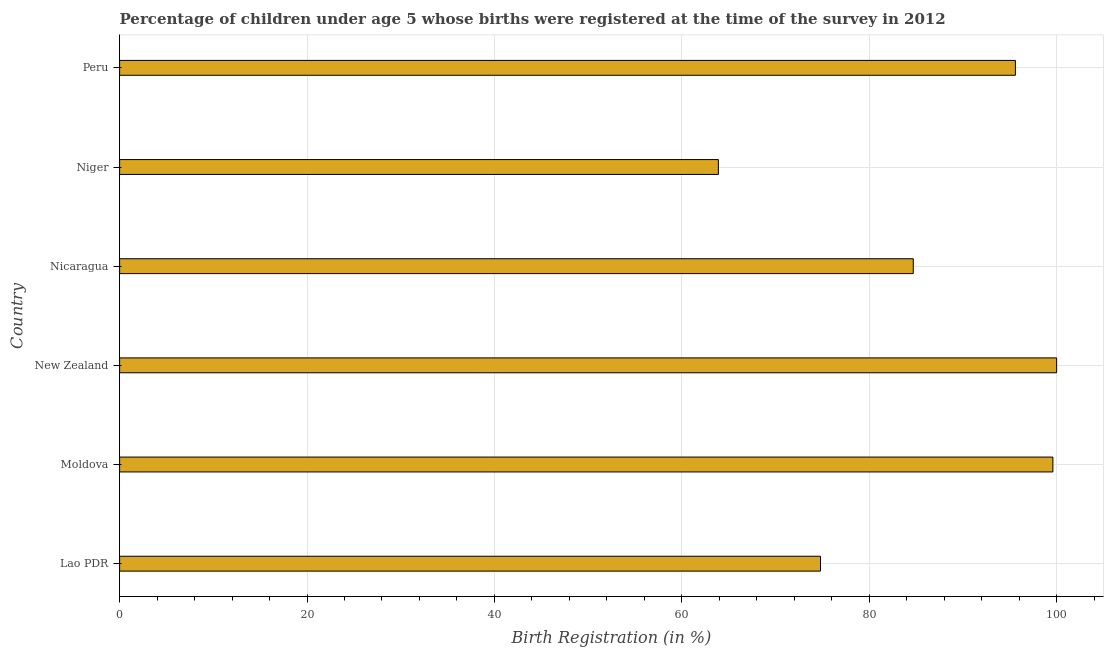Does the graph contain grids?
Keep it short and to the point. Yes. What is the title of the graph?
Your answer should be very brief. Percentage of children under age 5 whose births were registered at the time of the survey in 2012. What is the label or title of the X-axis?
Make the answer very short. Birth Registration (in %). What is the label or title of the Y-axis?
Your answer should be very brief. Country. What is the birth registration in Peru?
Give a very brief answer. 95.6. Across all countries, what is the maximum birth registration?
Keep it short and to the point. 100. Across all countries, what is the minimum birth registration?
Keep it short and to the point. 63.9. In which country was the birth registration maximum?
Offer a very short reply. New Zealand. In which country was the birth registration minimum?
Make the answer very short. Niger. What is the sum of the birth registration?
Provide a short and direct response. 518.6. What is the average birth registration per country?
Keep it short and to the point. 86.43. What is the median birth registration?
Provide a succinct answer. 90.15. In how many countries, is the birth registration greater than 52 %?
Ensure brevity in your answer.  6. What is the ratio of the birth registration in Lao PDR to that in Peru?
Ensure brevity in your answer.  0.78. What is the difference between the highest and the lowest birth registration?
Give a very brief answer. 36.1. In how many countries, is the birth registration greater than the average birth registration taken over all countries?
Your response must be concise. 3. How many bars are there?
Make the answer very short. 6. Are all the bars in the graph horizontal?
Your answer should be compact. Yes. How many countries are there in the graph?
Ensure brevity in your answer.  6. Are the values on the major ticks of X-axis written in scientific E-notation?
Provide a succinct answer. No. What is the Birth Registration (in %) in Lao PDR?
Your answer should be very brief. 74.8. What is the Birth Registration (in %) of Moldova?
Ensure brevity in your answer.  99.6. What is the Birth Registration (in %) of New Zealand?
Provide a succinct answer. 100. What is the Birth Registration (in %) in Nicaragua?
Your response must be concise. 84.7. What is the Birth Registration (in %) of Niger?
Provide a succinct answer. 63.9. What is the Birth Registration (in %) in Peru?
Give a very brief answer. 95.6. What is the difference between the Birth Registration (in %) in Lao PDR and Moldova?
Your answer should be compact. -24.8. What is the difference between the Birth Registration (in %) in Lao PDR and New Zealand?
Keep it short and to the point. -25.2. What is the difference between the Birth Registration (in %) in Lao PDR and Nicaragua?
Your answer should be compact. -9.9. What is the difference between the Birth Registration (in %) in Lao PDR and Peru?
Ensure brevity in your answer.  -20.8. What is the difference between the Birth Registration (in %) in Moldova and New Zealand?
Your answer should be compact. -0.4. What is the difference between the Birth Registration (in %) in Moldova and Nicaragua?
Your answer should be very brief. 14.9. What is the difference between the Birth Registration (in %) in Moldova and Niger?
Your answer should be compact. 35.7. What is the difference between the Birth Registration (in %) in Moldova and Peru?
Offer a very short reply. 4. What is the difference between the Birth Registration (in %) in New Zealand and Nicaragua?
Give a very brief answer. 15.3. What is the difference between the Birth Registration (in %) in New Zealand and Niger?
Make the answer very short. 36.1. What is the difference between the Birth Registration (in %) in New Zealand and Peru?
Provide a succinct answer. 4.4. What is the difference between the Birth Registration (in %) in Nicaragua and Niger?
Make the answer very short. 20.8. What is the difference between the Birth Registration (in %) in Nicaragua and Peru?
Keep it short and to the point. -10.9. What is the difference between the Birth Registration (in %) in Niger and Peru?
Ensure brevity in your answer.  -31.7. What is the ratio of the Birth Registration (in %) in Lao PDR to that in Moldova?
Make the answer very short. 0.75. What is the ratio of the Birth Registration (in %) in Lao PDR to that in New Zealand?
Your response must be concise. 0.75. What is the ratio of the Birth Registration (in %) in Lao PDR to that in Nicaragua?
Your response must be concise. 0.88. What is the ratio of the Birth Registration (in %) in Lao PDR to that in Niger?
Provide a succinct answer. 1.17. What is the ratio of the Birth Registration (in %) in Lao PDR to that in Peru?
Offer a terse response. 0.78. What is the ratio of the Birth Registration (in %) in Moldova to that in Nicaragua?
Offer a terse response. 1.18. What is the ratio of the Birth Registration (in %) in Moldova to that in Niger?
Keep it short and to the point. 1.56. What is the ratio of the Birth Registration (in %) in Moldova to that in Peru?
Provide a short and direct response. 1.04. What is the ratio of the Birth Registration (in %) in New Zealand to that in Nicaragua?
Keep it short and to the point. 1.18. What is the ratio of the Birth Registration (in %) in New Zealand to that in Niger?
Provide a short and direct response. 1.56. What is the ratio of the Birth Registration (in %) in New Zealand to that in Peru?
Offer a very short reply. 1.05. What is the ratio of the Birth Registration (in %) in Nicaragua to that in Niger?
Your response must be concise. 1.33. What is the ratio of the Birth Registration (in %) in Nicaragua to that in Peru?
Make the answer very short. 0.89. What is the ratio of the Birth Registration (in %) in Niger to that in Peru?
Keep it short and to the point. 0.67. 